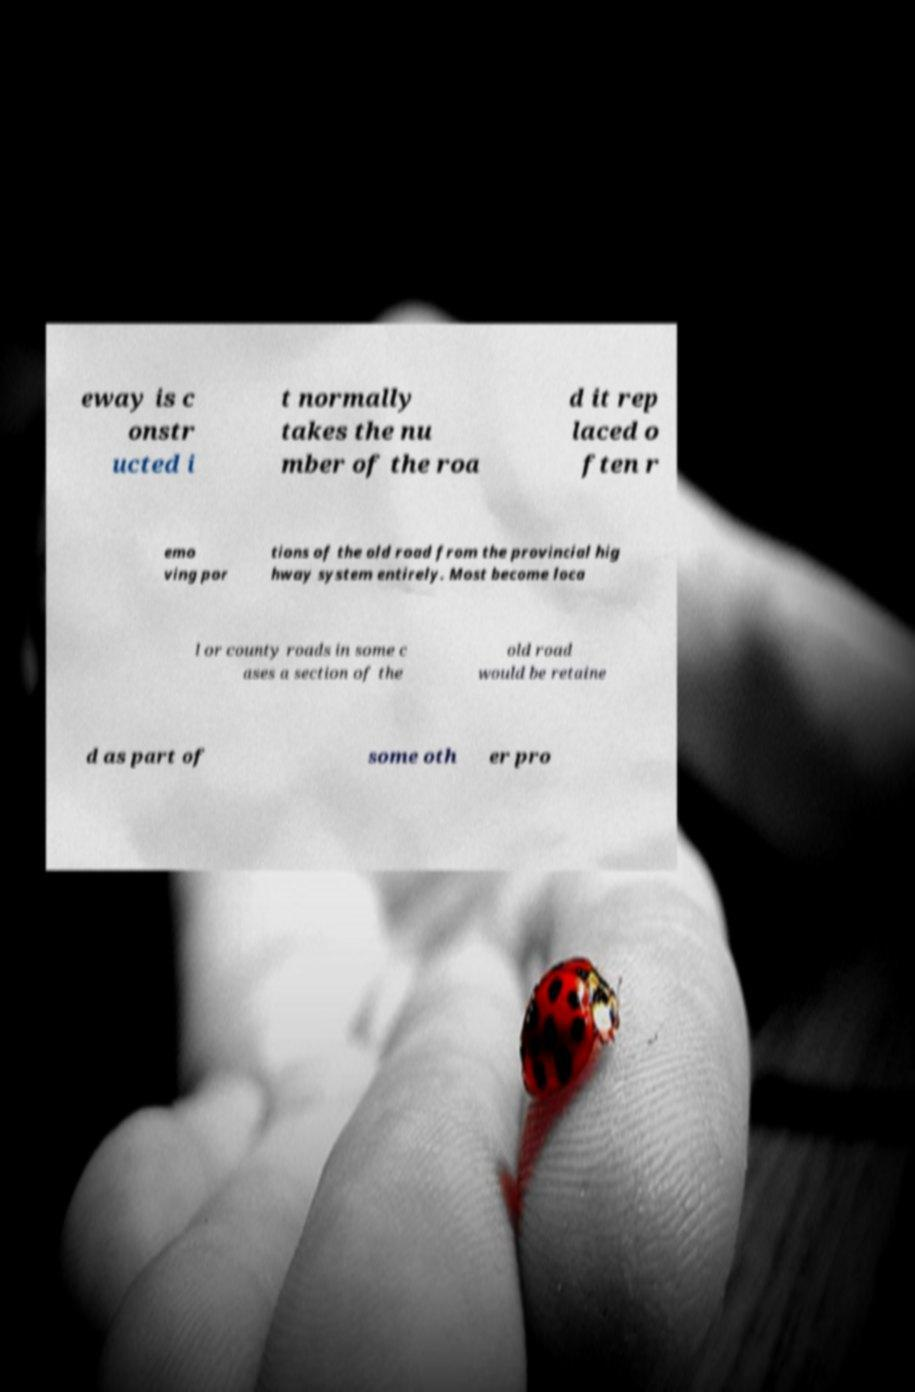What messages or text are displayed in this image? I need them in a readable, typed format. eway is c onstr ucted i t normally takes the nu mber of the roa d it rep laced o ften r emo ving por tions of the old road from the provincial hig hway system entirely. Most become loca l or county roads in some c ases a section of the old road would be retaine d as part of some oth er pro 